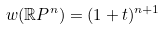<formula> <loc_0><loc_0><loc_500><loc_500>w ( \mathbb { R } P ^ { n } ) = ( 1 + t ) ^ { n + 1 }</formula> 